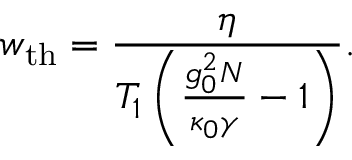Convert formula to latex. <formula><loc_0><loc_0><loc_500><loc_500>w _ { t h } = \frac { \eta } { T _ { 1 } \left ( \frac { g _ { 0 } ^ { 2 } N } { \kappa _ { 0 } \gamma } - 1 \right ) } .</formula> 